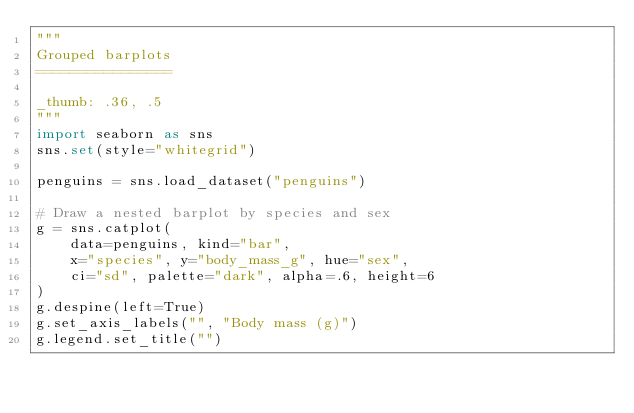<code> <loc_0><loc_0><loc_500><loc_500><_Python_>"""
Grouped barplots
================

_thumb: .36, .5
"""
import seaborn as sns
sns.set(style="whitegrid")

penguins = sns.load_dataset("penguins")

# Draw a nested barplot by species and sex
g = sns.catplot(
    data=penguins, kind="bar",
    x="species", y="body_mass_g", hue="sex",
    ci="sd", palette="dark", alpha=.6, height=6
)
g.despine(left=True)
g.set_axis_labels("", "Body mass (g)")
g.legend.set_title("")
</code> 